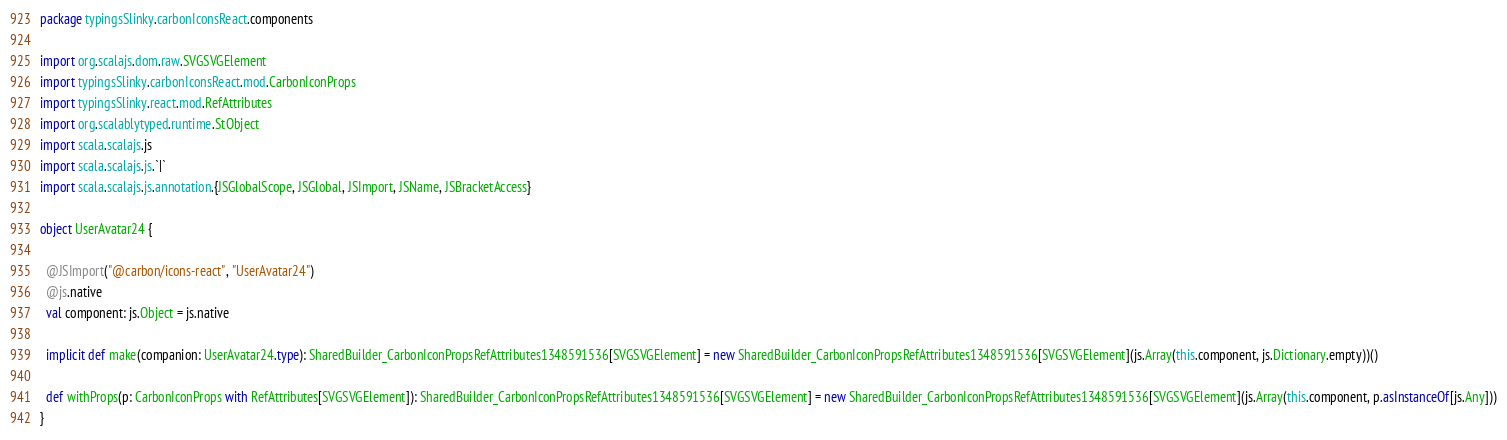Convert code to text. <code><loc_0><loc_0><loc_500><loc_500><_Scala_>package typingsSlinky.carbonIconsReact.components

import org.scalajs.dom.raw.SVGSVGElement
import typingsSlinky.carbonIconsReact.mod.CarbonIconProps
import typingsSlinky.react.mod.RefAttributes
import org.scalablytyped.runtime.StObject
import scala.scalajs.js
import scala.scalajs.js.`|`
import scala.scalajs.js.annotation.{JSGlobalScope, JSGlobal, JSImport, JSName, JSBracketAccess}

object UserAvatar24 {
  
  @JSImport("@carbon/icons-react", "UserAvatar24")
  @js.native
  val component: js.Object = js.native
  
  implicit def make(companion: UserAvatar24.type): SharedBuilder_CarbonIconPropsRefAttributes1348591536[SVGSVGElement] = new SharedBuilder_CarbonIconPropsRefAttributes1348591536[SVGSVGElement](js.Array(this.component, js.Dictionary.empty))()
  
  def withProps(p: CarbonIconProps with RefAttributes[SVGSVGElement]): SharedBuilder_CarbonIconPropsRefAttributes1348591536[SVGSVGElement] = new SharedBuilder_CarbonIconPropsRefAttributes1348591536[SVGSVGElement](js.Array(this.component, p.asInstanceOf[js.Any]))
}
</code> 